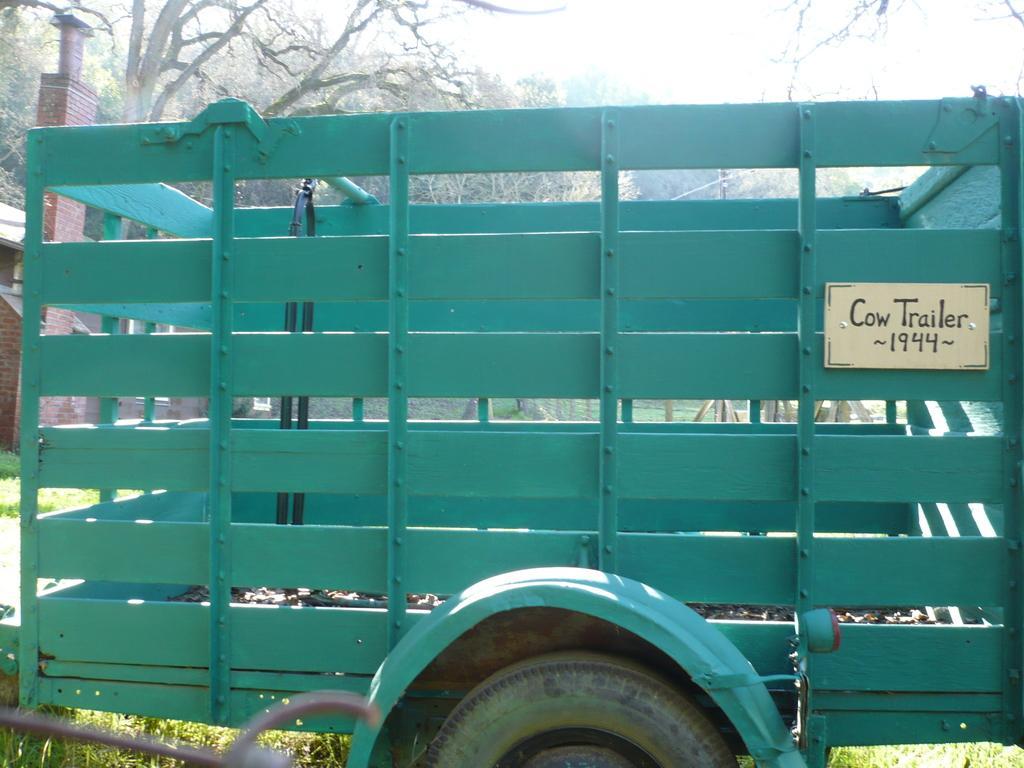In one or two sentences, can you explain what this image depicts? In the center of the image, we can see a vehicle and there is a board with some text. In the background, there are trees and there is a shed. At the bottom, there is ground. 